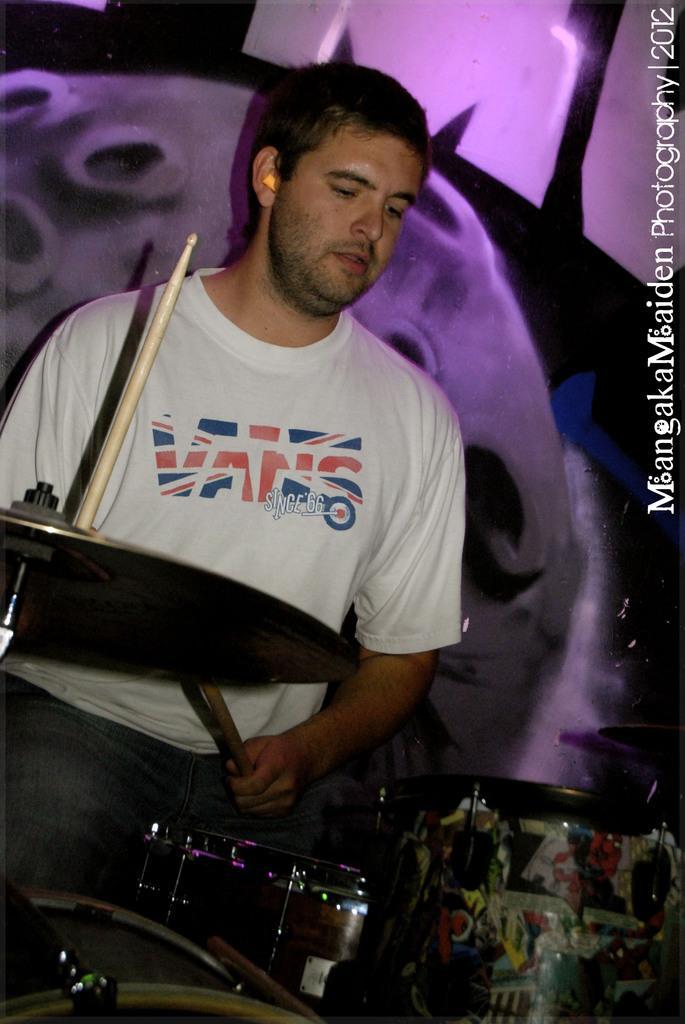How would you summarize this image in a sentence or two? This is the picture of a man who is playing drums. He is wearing white st shirt and pant. he is holding drumsticks. The background is purple in color. 